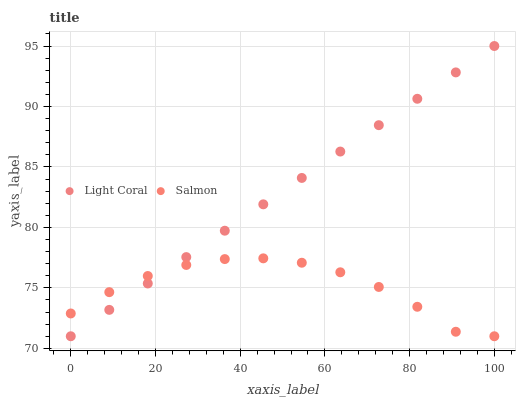Does Salmon have the minimum area under the curve?
Answer yes or no. Yes. Does Light Coral have the maximum area under the curve?
Answer yes or no. Yes. Does Salmon have the maximum area under the curve?
Answer yes or no. No. Is Light Coral the smoothest?
Answer yes or no. Yes. Is Salmon the roughest?
Answer yes or no. Yes. Is Salmon the smoothest?
Answer yes or no. No. Does Light Coral have the lowest value?
Answer yes or no. Yes. Does Light Coral have the highest value?
Answer yes or no. Yes. Does Salmon have the highest value?
Answer yes or no. No. Does Light Coral intersect Salmon?
Answer yes or no. Yes. Is Light Coral less than Salmon?
Answer yes or no. No. Is Light Coral greater than Salmon?
Answer yes or no. No. 